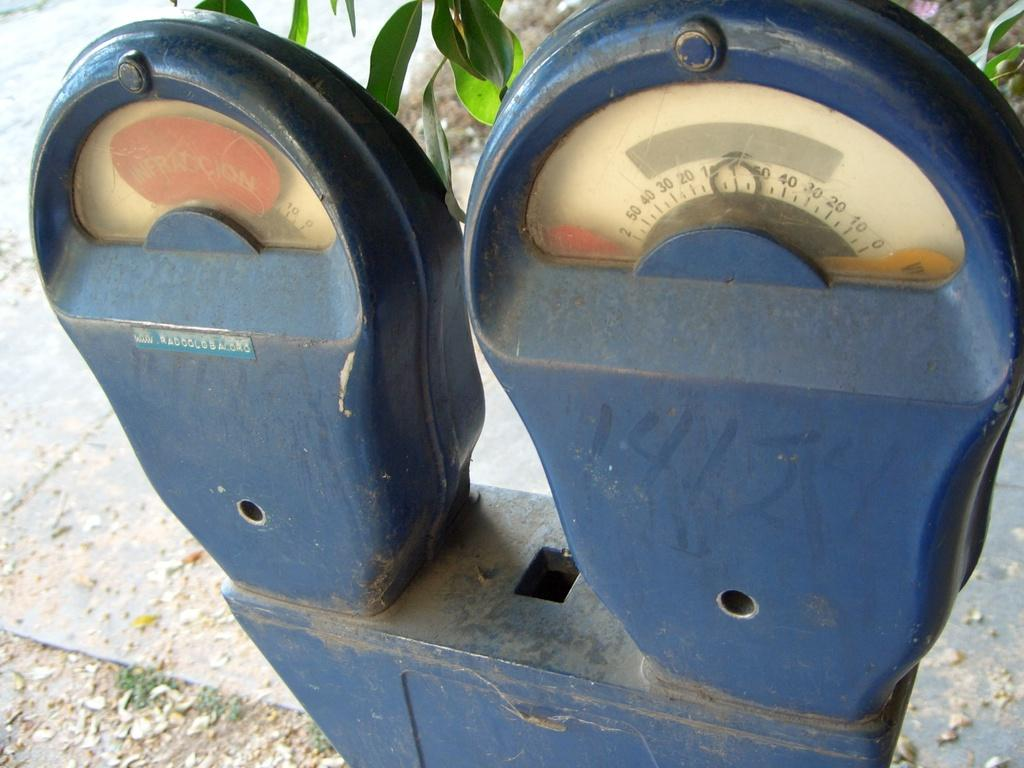<image>
Present a compact description of the photo's key features. The parking meter is on red and states infraccion. 